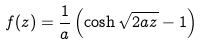<formula> <loc_0><loc_0><loc_500><loc_500>f ( z ) = \frac { 1 } { a } \left ( \cosh \sqrt { 2 a z } - 1 \right )</formula> 